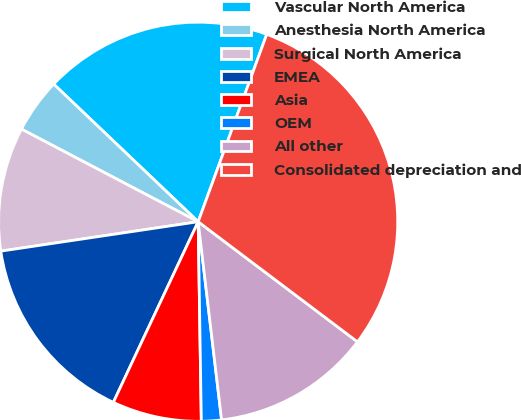<chart> <loc_0><loc_0><loc_500><loc_500><pie_chart><fcel>Vascular North America<fcel>Anesthesia North America<fcel>Surgical North America<fcel>EMEA<fcel>Asia<fcel>OEM<fcel>All other<fcel>Consolidated depreciation and<nl><fcel>18.47%<fcel>4.43%<fcel>10.04%<fcel>15.66%<fcel>7.24%<fcel>1.62%<fcel>12.85%<fcel>29.7%<nl></chart> 